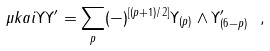Convert formula to latex. <formula><loc_0><loc_0><loc_500><loc_500>\mu k a i { \Upsilon } { \Upsilon ^ { \prime } } = \sum _ { p } ( - ) ^ { [ ( p + 1 ) / 2 ] } \Upsilon _ { ( p ) } \wedge \Upsilon ^ { \prime } _ { ( 6 - p ) } \ ,</formula> 